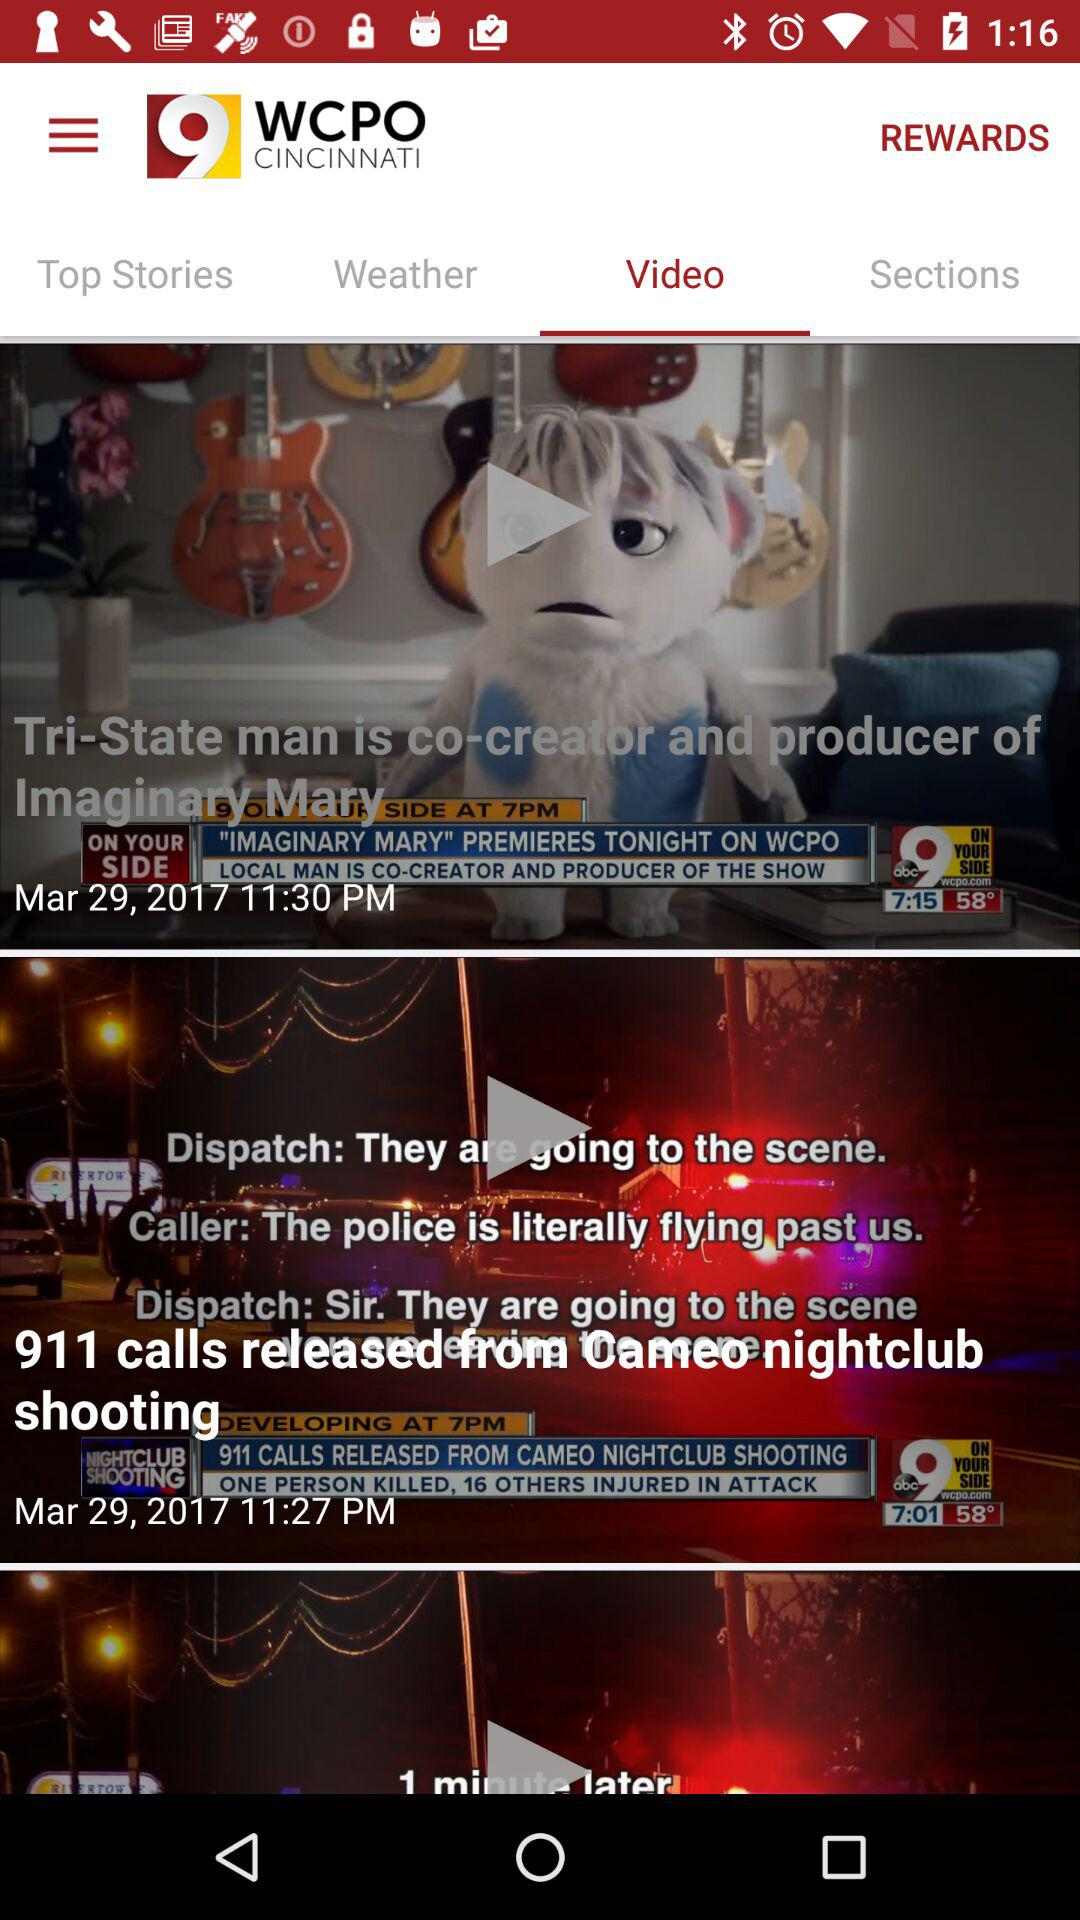Which tab is selected? The selected tab is "Video". 